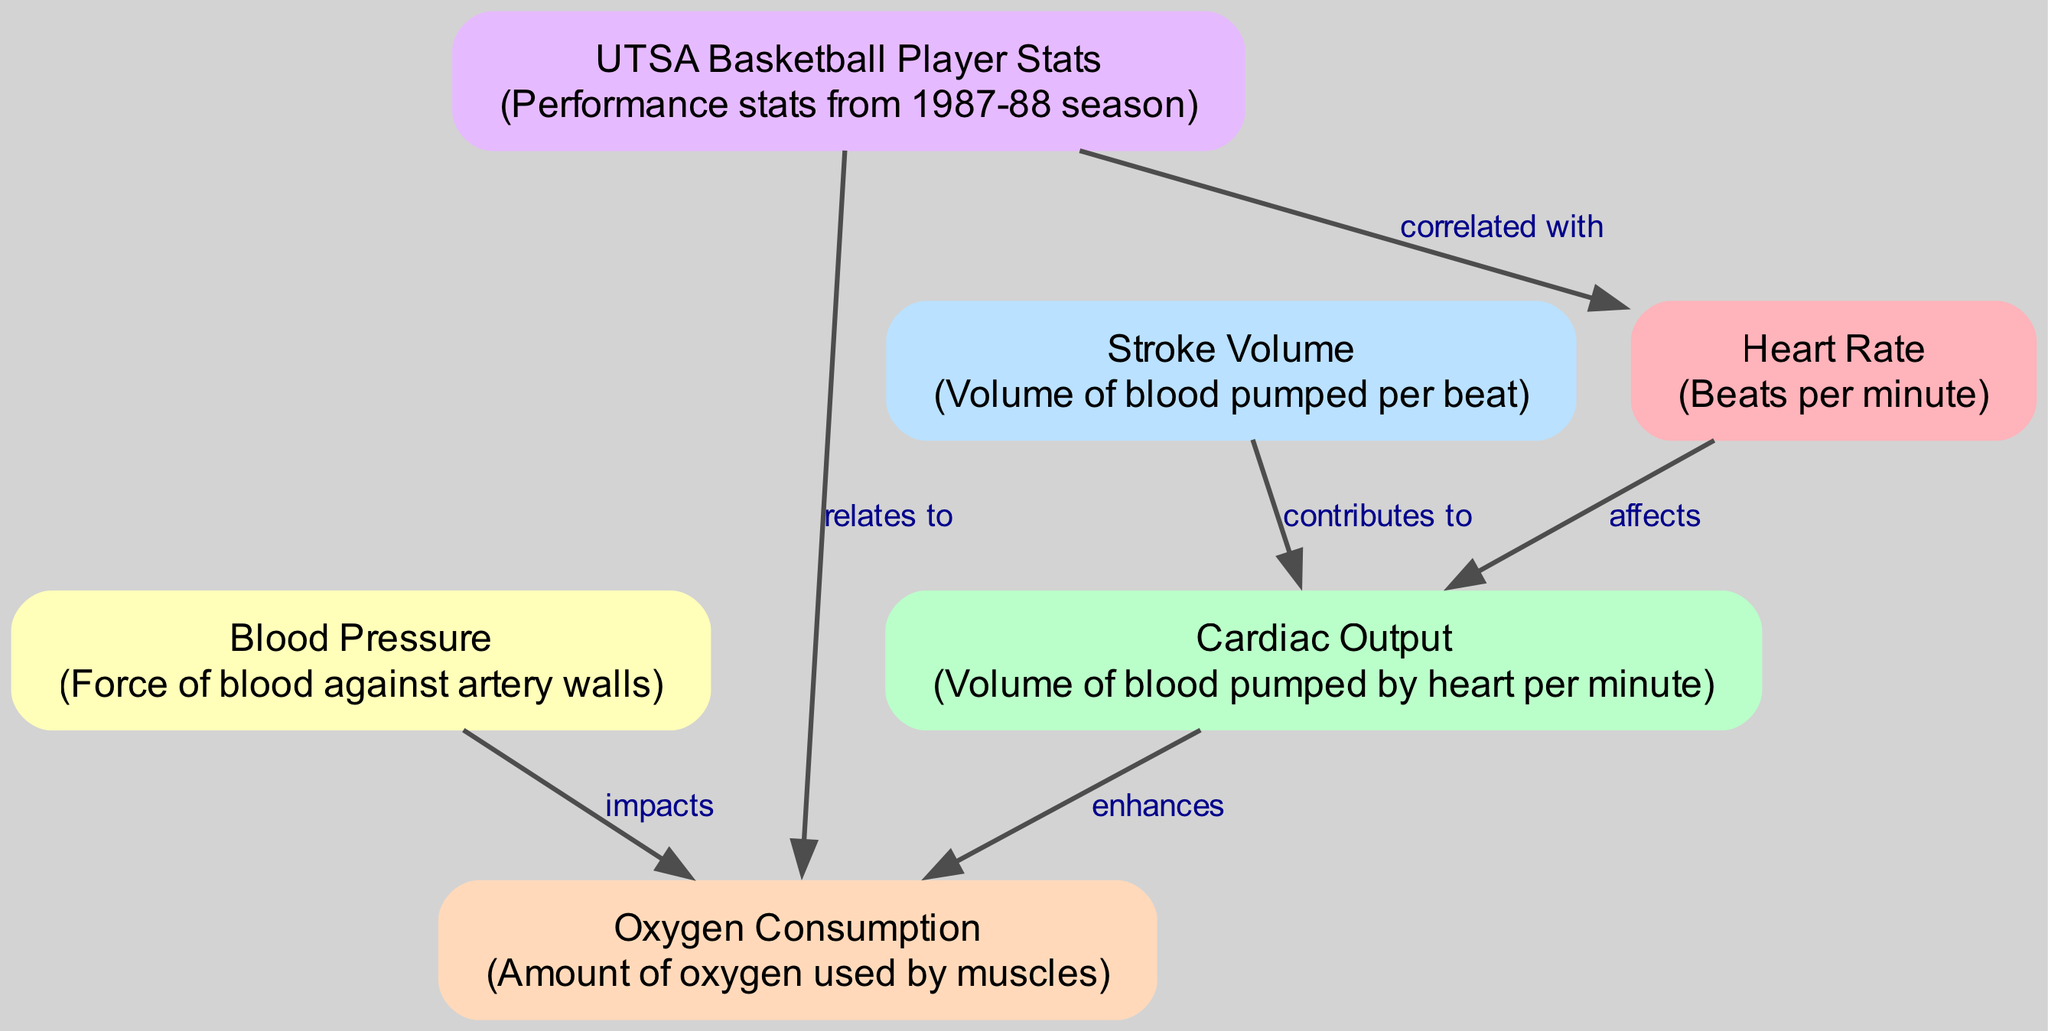What is the relationship between heart rate and cardiac output? The diagram indicates that heart rate "affects" cardiac output, which means an increase in heart rate likely leads to an increase in cardiac output.
Answer: affects How many nodes are present in the diagram? The diagram includes 6 distinct nodes: heart rate, cardiac output, stroke volume, blood pressure, oxygen consumption, and UTSA basketball player stats.
Answer: 6 What type of impact does blood pressure have on oxygen consumption? The diagram shows that blood pressure "impacts" oxygen consumption, indicating a direct relationship where changes in blood pressure affect the amount of oxygen consumed.
Answer: impacts Which element contributes to cardiac output? The diagram illustrates that stroke volume "contributes to" cardiac output, meaning that the volume of blood pumped per beat plays a role in the total volume pumped by the heart per minute.
Answer: contributes to What can be inferred about player stats in relation to heart rate? The diagram states that UTSA basketball player stats are "correlated with" heart rate, suggesting that there is a statistical relationship between player performance during the 1987-88 season and their heart rates.
Answer: correlated with How does cardiac output influence oxygen consumption? The diagram indicates that cardiac output "enhances" oxygen consumption, meaning that increased cardiac output allows for more oxygen to be delivered to the muscles during exercise.
Answer: enhances What is the main performance factor related to the UTSA basketball players that affects heart rate? The diagram reveals that UTSA basketball player stats are the main performance factor that "correlated with" heart rate, suggesting their performance influences how fast their hearts beat during exercise.
Answer: correlated with Is there any relation between blood pressure and cardiac output in the diagram? The diagram does not explicitly show a relationship between blood pressure and cardiac output, as there are no edges connecting these two nodes directly.
Answer: No What is the significance of stroke volume in the overall cardiovascular performance shown in the diagram? Stroke volume is significant as it "contributes to" cardiac output, which is a critical factor in determining overall cardiovascular performance during exercise, reflecting how much blood is pumped with each heartbeat.
Answer: contributes to 